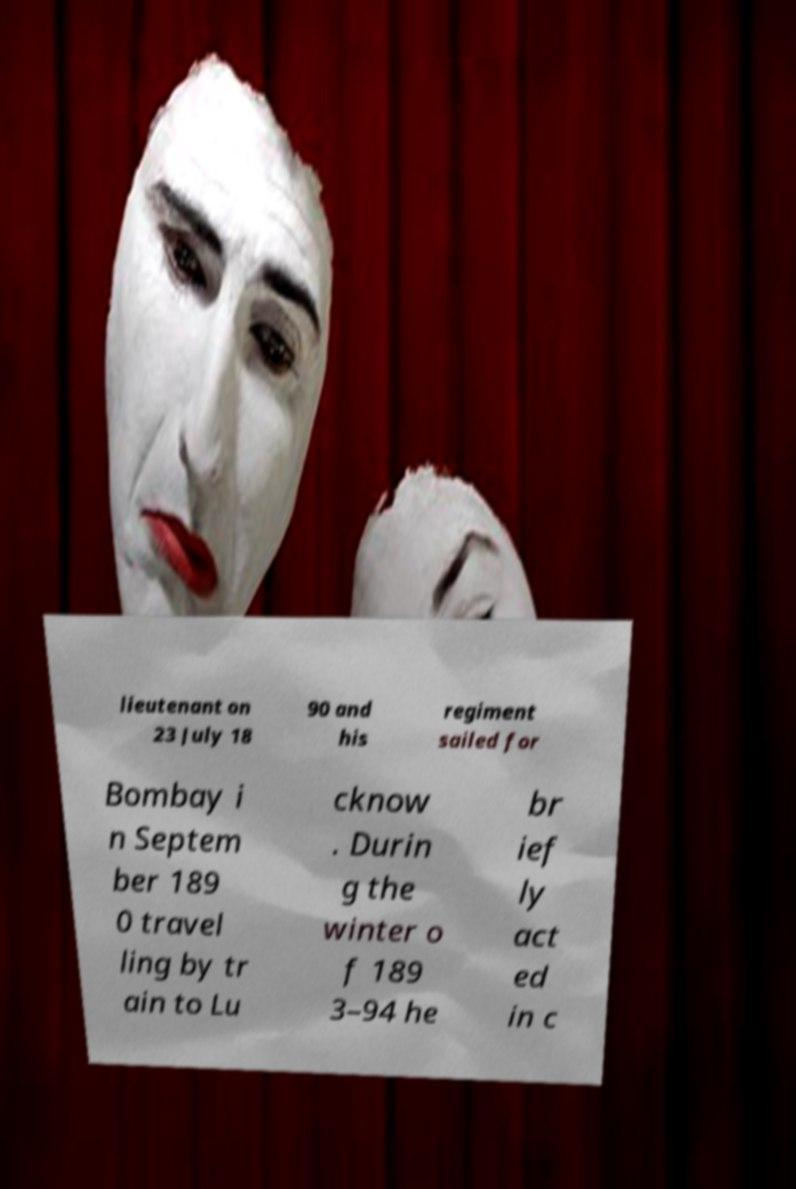Please identify and transcribe the text found in this image. lieutenant on 23 July 18 90 and his regiment sailed for Bombay i n Septem ber 189 0 travel ling by tr ain to Lu cknow . Durin g the winter o f 189 3–94 he br ief ly act ed in c 